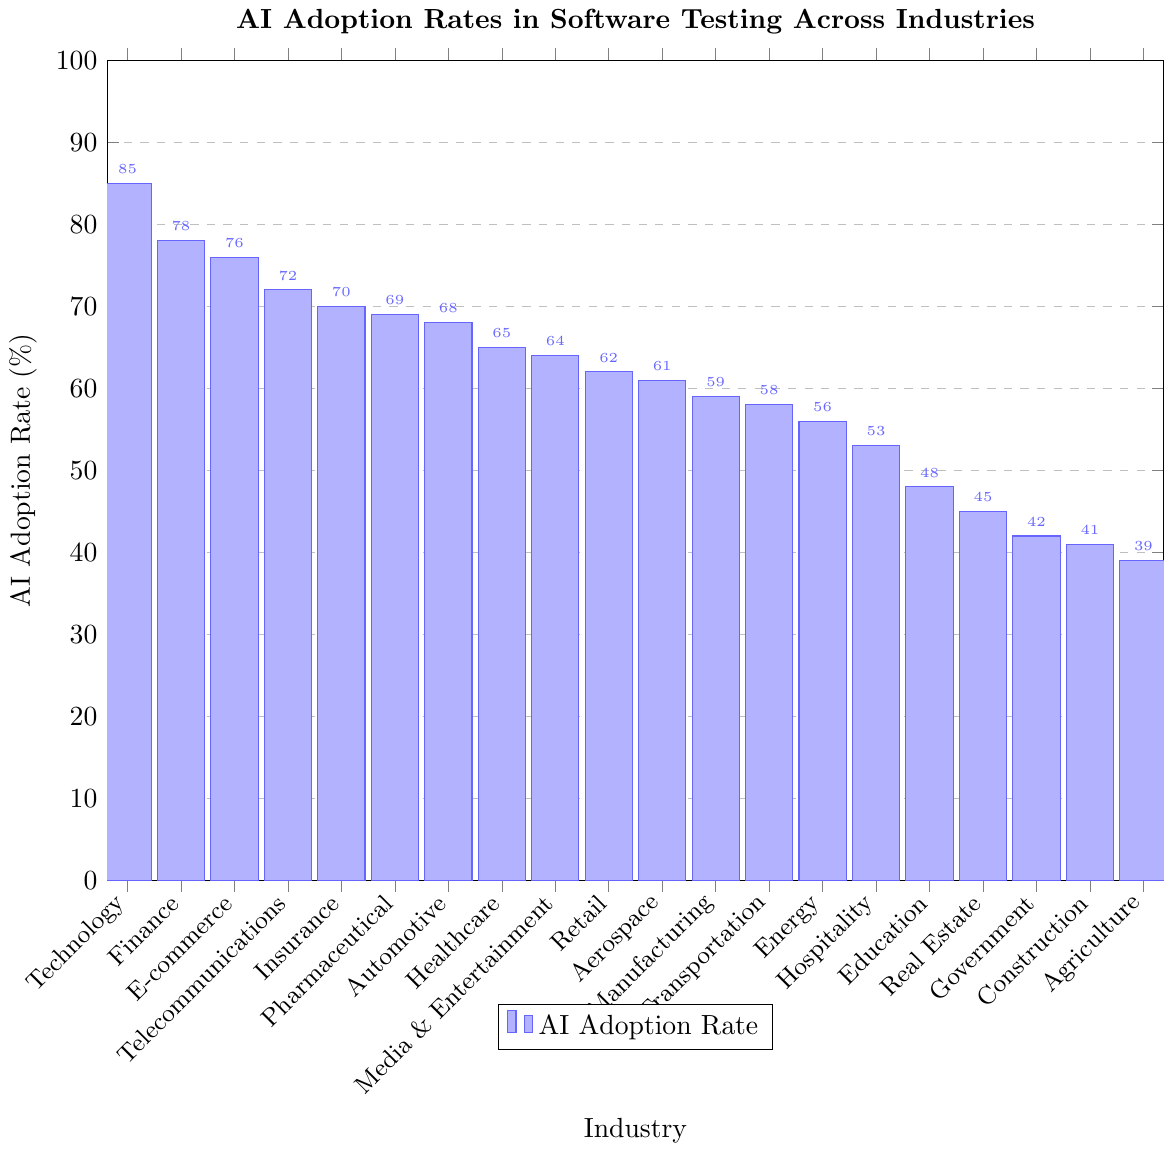Which industry has the highest AI adoption rate in software testing? The bar chart shows the AI adoption rates across various industries, and the tallest bar represents the industry with the highest adoption rate. The "Technology" industry has the highest adoption rate at 85%.
Answer: Technology Which industry has the lowest AI adoption rate in software testing? The shortest bar in the bar chart corresponds to the industry with the lowest AI adoption rate. The "Agriculture" industry has the lowest adoption rate at 39%.
Answer: Agriculture What is the difference in AI adoption rates between the Technology and Healthcare industries? The AI adoption rate for the Technology industry is 85%, and for the Healthcare industry, it is 65%. Subtracting these values gives us 85% - 65% = 20%.
Answer: 20% Which industries have an AI adoption rate greater than 70%? The industries with bars above the 70% mark on the y-axis are "Technology," "Finance," "E-commerce," "Telecommunications," and "Insurance." Their respective adoption rates are 85%, 78%, 76%, 72%, and 70%.
Answer: Technology, Finance, E-commerce, Telecommunications, Insurance By how much does the AI adoption rate in the E-commerce industry exceed that of the Retail industry? The AI adoption rate for the E-commerce industry is 76%, while for the Retail industry, it is 62%. The difference is 76% - 62% = 14%.
Answer: 14% What is the average AI adoption rate across all industries? To find the average adoption rate, we sum all the individual rates and divide by the number of industries. The sum is 78 + 65 + 62 + 59 + 72 + 68 + 85 + 56 + 48 + 42 + 76 + 70 + 64 + 58 + 61 + 69 + 45 + 39 + 53 + 41 = 1271. There are 20 industries, so the average is 1271 / 20 = 63.55%.
Answer: 63.55% Which industry has a higher AI adoption rate: Government or Construction? Comparing the heights of the bars for these two industries, the Construction industry has an adoption rate of 41%, while the Government industry has a rate of 42%. Therefore, the Government industry has a slightly higher adoption rate than Construction.
Answer: Government What is the median AI adoption rate among the listed industries? First, list the rates in ascending order: 39, 41, 42, 45, 48, 53, 56, 58, 59, 61, 62, 64, 65, 68, 69, 70, 72, 76, 78, 85. For 20 data points, the median is the average of the 10th and 11th values. The 10th value is 61 and the 11th is 62, so the median is (61 + 62) / 2 = 61.5%.
Answer: 61.5% What is the total AI adoption rate for the Automotive, Pharmaceutical, and Media & Entertainment industries combined? Add the AI adoption rates for these industries: Automotive (68%), Pharmaceutical (69%), and Media & Entertainment (64%). The sum is 68 + 69 + 64 = 201%.
Answer: 201% Are there more industries with adoption rates above or below 60%? Count the number of industries with rates above and below 60%. Above: 85, 78, 76, 72, 70, 69, 68, 65, 64, 62 - a total of 10 industries. Below: 59, 58, 56, 53, 48, 45, 42, 41, 39 - a total of 9 industries. There are more industries with adoption rates above 60%.
Answer: Above 